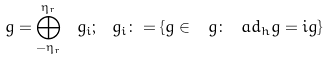<formula> <loc_0><loc_0><loc_500><loc_500>\ g = \bigoplus _ { - \eta _ { r } } ^ { \eta _ { r } } \ g _ { i } ; \ g _ { i } \colon = \{ g \in \ g \colon \ a d _ { h } g = i g \}</formula> 